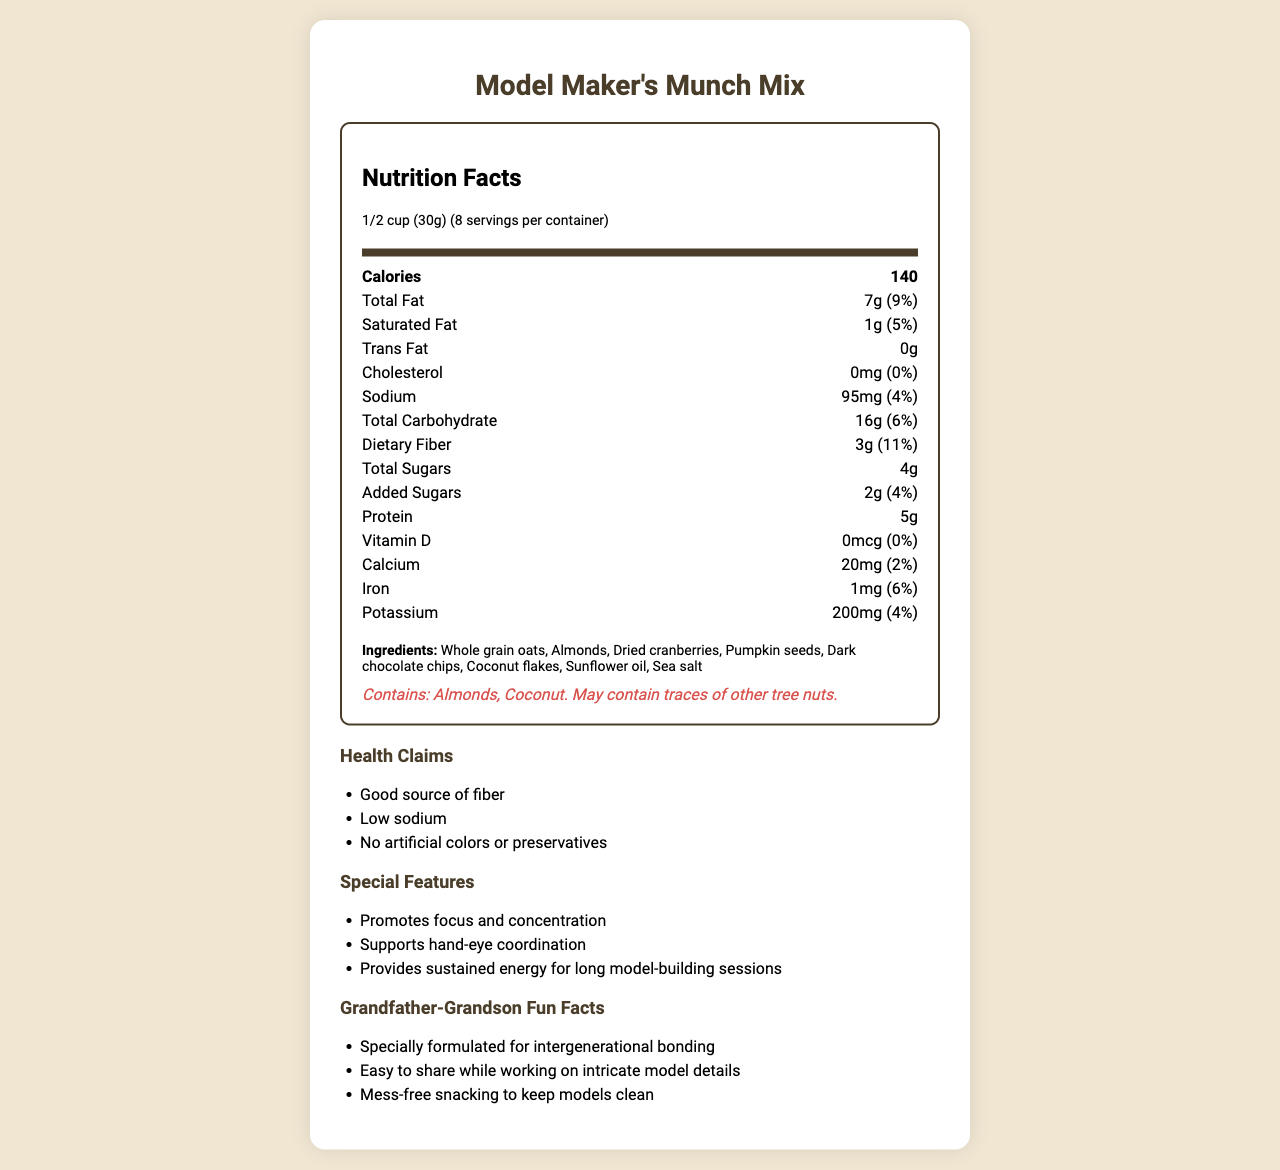what is the serving size of Model Maker's Munch Mix? The serving size is clearly stated at the top of the nutrition facts section.
Answer: 1/2 cup (30g) how many total servings are in the container? The number of servings per container is listed in the serving information.
Answer: 8 how much protein is in one serving? The amount of protein per serving is listed under the nutrition items.
Answer: 5g what is the percentage daily value of dietary fiber per serving? The percent daily value of dietary fiber is shown in parentheses next to the amount.
Answer: 11% what are the ingredients of the snack mix? The ingredients are listed near the end of the document under the ingredients section.
Answer: Whole grain oats, Almonds, Dried cranberries, Pumpkin seeds, Dark chocolate chips, Coconut flakes, Sunflower oil, Sea salt which of the following health claims is made about the snack mix? A. High in protein B. Good source of fiber C. Low in sugar The health claims are listed under the health claims section, which includes "Good source of fiber."
Answer: B what feature of the snack mix is designed to help with focus? A. Provides sustained energy B. Supports hand-eye coordination C. Promotes focus and concentration "Promotes focus and concentration" is mentioned under the special features section.
Answer: C is there any cholesterol in the snack mix? The nutrition facts state that the amount of cholesterol is 0mg with a 0% daily value.
Answer: No are there any allergens in the snack mix? The allergen information section states that it contains almonds and coconut and may contain traces of other tree nuts.
Answer: Yes describe the purpose of the special features section of the document. This section is meant to emphasize how the snack mix can be a useful addition to activities requiring focus and dexterity.
Answer: The special features section highlights the benefits of the snack mix that are specifically aligned with activities like model building, such as promoting focus and concentration, supporting hand-eye coordination, and providing sustained energy. what is the company's primary goal for producing Model Maker's Munch Mix? The document outlines the nutritional content, ingredients, and benefits of the snack mix, but it does not state the company’s primary goal or mission.
Answer: Cannot be determined 